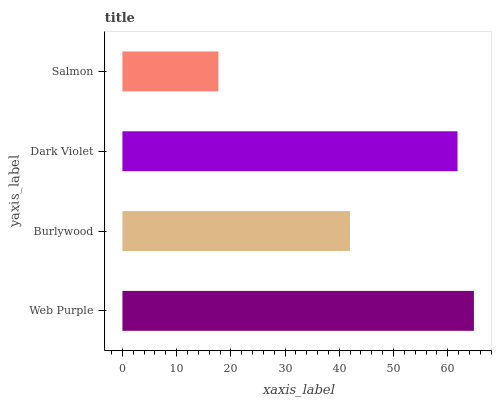Is Salmon the minimum?
Answer yes or no. Yes. Is Web Purple the maximum?
Answer yes or no. Yes. Is Burlywood the minimum?
Answer yes or no. No. Is Burlywood the maximum?
Answer yes or no. No. Is Web Purple greater than Burlywood?
Answer yes or no. Yes. Is Burlywood less than Web Purple?
Answer yes or no. Yes. Is Burlywood greater than Web Purple?
Answer yes or no. No. Is Web Purple less than Burlywood?
Answer yes or no. No. Is Dark Violet the high median?
Answer yes or no. Yes. Is Burlywood the low median?
Answer yes or no. Yes. Is Web Purple the high median?
Answer yes or no. No. Is Salmon the low median?
Answer yes or no. No. 